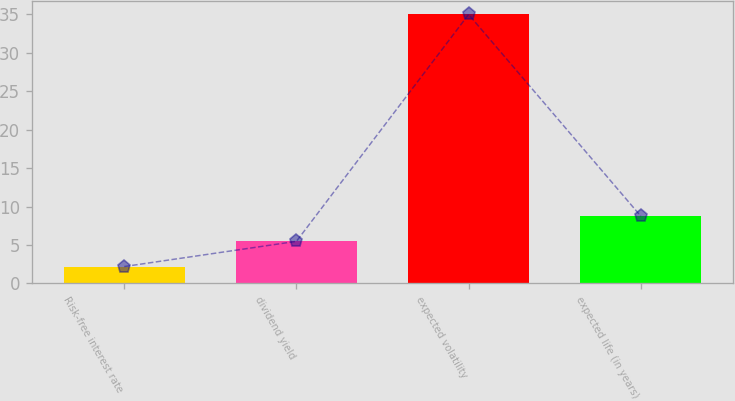Convert chart to OTSL. <chart><loc_0><loc_0><loc_500><loc_500><bar_chart><fcel>Risk-free interest rate<fcel>dividend yield<fcel>expected volatility<fcel>expected life (in years)<nl><fcel>2.2<fcel>5.48<fcel>35<fcel>8.76<nl></chart> 